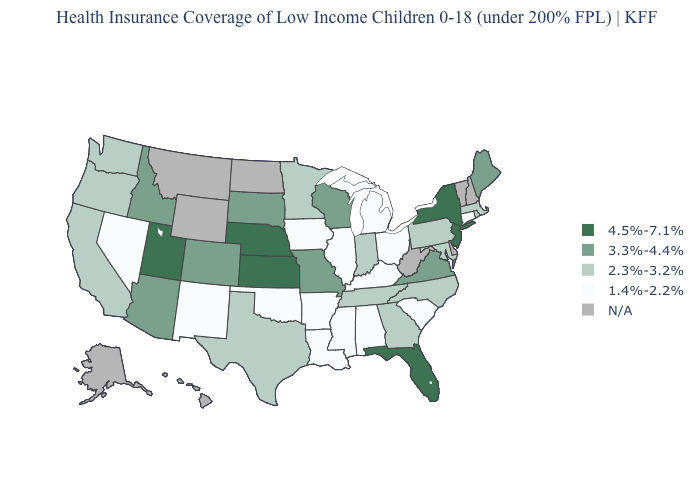Does the map have missing data?
Answer briefly. Yes. What is the lowest value in states that border South Carolina?
Short answer required. 2.3%-3.2%. Which states have the lowest value in the USA?
Be succinct. Alabama, Arkansas, Connecticut, Illinois, Iowa, Kentucky, Louisiana, Michigan, Mississippi, Nevada, New Mexico, Ohio, Oklahoma, South Carolina. Among the states that border Kansas , which have the highest value?
Write a very short answer. Nebraska. Which states have the lowest value in the USA?
Be succinct. Alabama, Arkansas, Connecticut, Illinois, Iowa, Kentucky, Louisiana, Michigan, Mississippi, Nevada, New Mexico, Ohio, Oklahoma, South Carolina. Name the states that have a value in the range 3.3%-4.4%?
Concise answer only. Arizona, Colorado, Idaho, Maine, Missouri, South Dakota, Virginia, Wisconsin. Name the states that have a value in the range 3.3%-4.4%?
Be succinct. Arizona, Colorado, Idaho, Maine, Missouri, South Dakota, Virginia, Wisconsin. Does Minnesota have the lowest value in the USA?
Keep it brief. No. Name the states that have a value in the range 4.5%-7.1%?
Write a very short answer. Florida, Kansas, Nebraska, New Jersey, New York, Utah. Name the states that have a value in the range N/A?
Short answer required. Alaska, Delaware, Hawaii, Montana, New Hampshire, North Dakota, Vermont, West Virginia, Wyoming. Which states hav the highest value in the West?
Short answer required. Utah. Name the states that have a value in the range 2.3%-3.2%?
Give a very brief answer. California, Georgia, Indiana, Maryland, Massachusetts, Minnesota, North Carolina, Oregon, Pennsylvania, Rhode Island, Tennessee, Texas, Washington. Does the map have missing data?
Short answer required. Yes. What is the value of Nevada?
Be succinct. 1.4%-2.2%. Name the states that have a value in the range 3.3%-4.4%?
Concise answer only. Arizona, Colorado, Idaho, Maine, Missouri, South Dakota, Virginia, Wisconsin. 